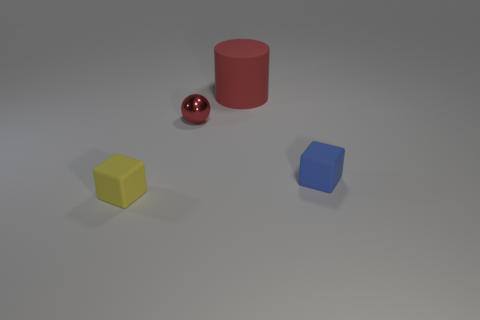What can you infer about the lighting in this scene? The lighting in the scene suggests a single light source, possibly overhead, given the way the shadows are cast directly beneath the objects, slightly towards the right. This creates soft-edged shadows indicating the light is diffused, not overly harsh or direct. 